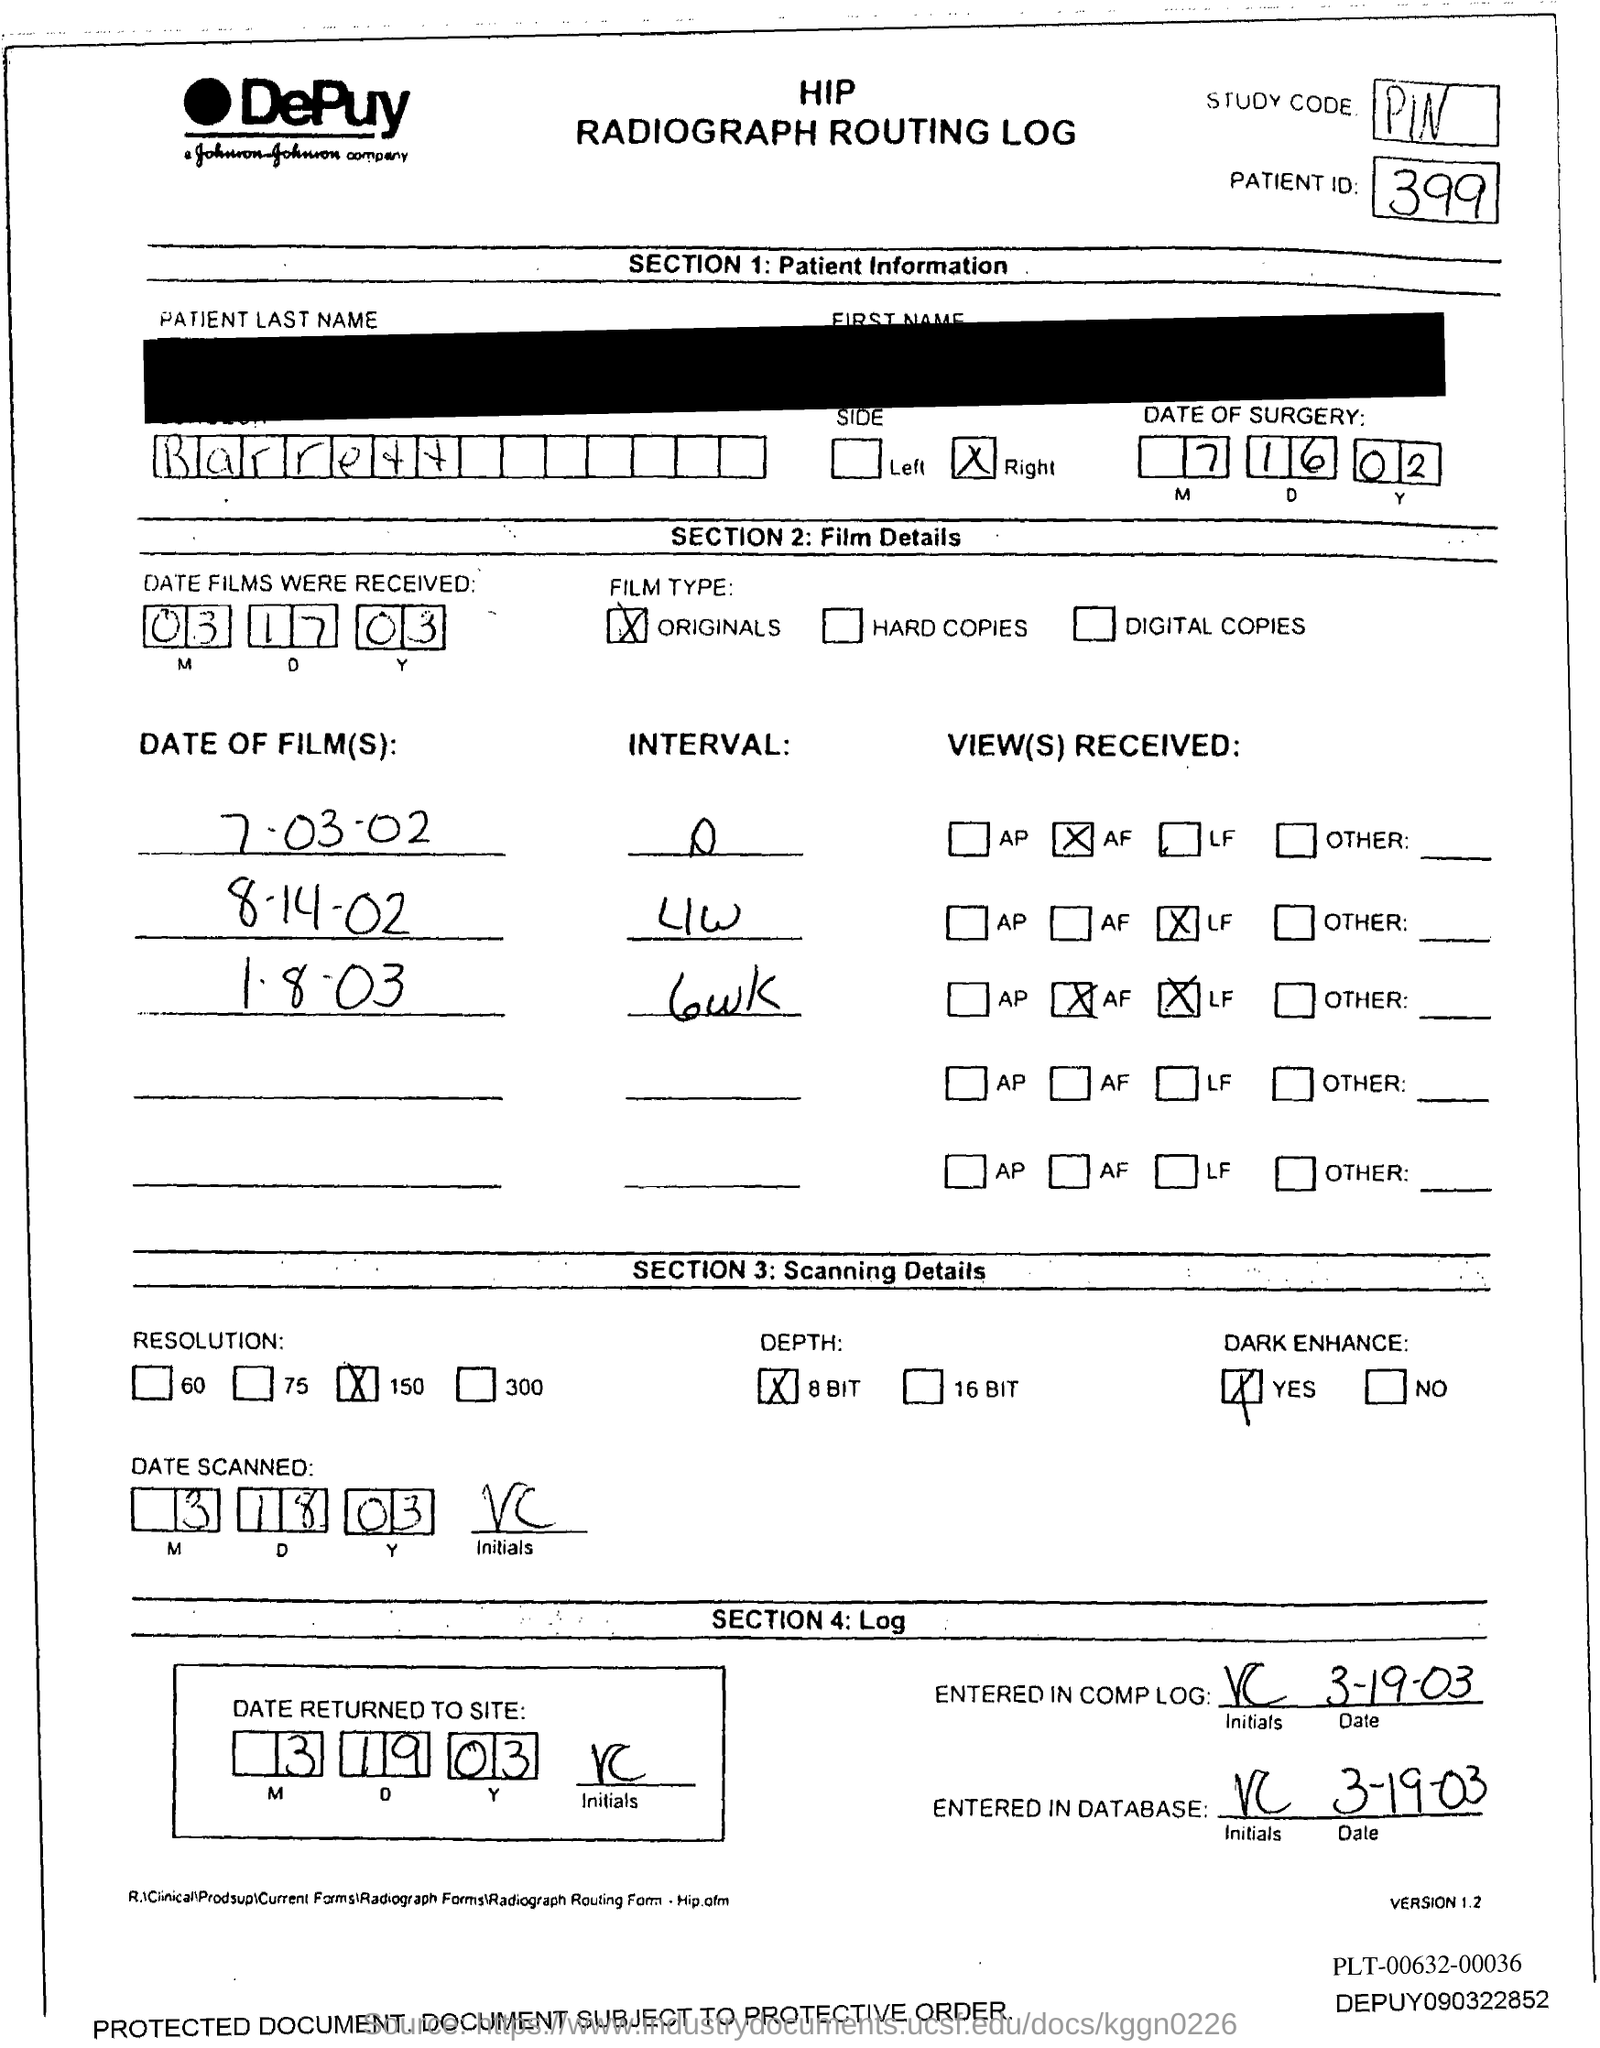List a handful of essential elements in this visual. What is the patient ID?" the nurse asked, looking at the patient ID on the chart. The patient ID was 399. The study code is PIN. 